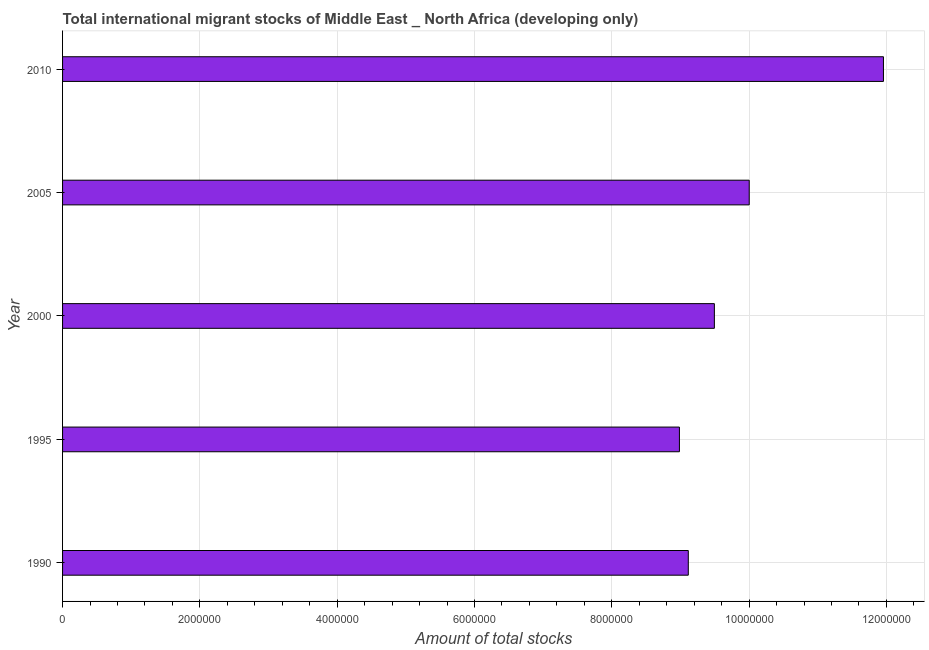What is the title of the graph?
Keep it short and to the point. Total international migrant stocks of Middle East _ North Africa (developing only). What is the label or title of the X-axis?
Offer a terse response. Amount of total stocks. What is the total number of international migrant stock in 1990?
Keep it short and to the point. 9.11e+06. Across all years, what is the maximum total number of international migrant stock?
Make the answer very short. 1.20e+07. Across all years, what is the minimum total number of international migrant stock?
Provide a short and direct response. 8.99e+06. What is the sum of the total number of international migrant stock?
Offer a terse response. 4.96e+07. What is the difference between the total number of international migrant stock in 2005 and 2010?
Provide a succinct answer. -1.96e+06. What is the average total number of international migrant stock per year?
Keep it short and to the point. 9.91e+06. What is the median total number of international migrant stock?
Your response must be concise. 9.49e+06. Do a majority of the years between 1990 and 2005 (inclusive) have total number of international migrant stock greater than 7200000 ?
Keep it short and to the point. Yes. What is the ratio of the total number of international migrant stock in 1995 to that in 2010?
Offer a very short reply. 0.75. Is the total number of international migrant stock in 1995 less than that in 2005?
Offer a very short reply. Yes. Is the difference between the total number of international migrant stock in 2005 and 2010 greater than the difference between any two years?
Give a very brief answer. No. What is the difference between the highest and the second highest total number of international migrant stock?
Offer a terse response. 1.96e+06. What is the difference between the highest and the lowest total number of international migrant stock?
Ensure brevity in your answer.  2.97e+06. In how many years, is the total number of international migrant stock greater than the average total number of international migrant stock taken over all years?
Offer a terse response. 2. Are all the bars in the graph horizontal?
Provide a short and direct response. Yes. How many years are there in the graph?
Make the answer very short. 5. What is the Amount of total stocks of 1990?
Keep it short and to the point. 9.11e+06. What is the Amount of total stocks in 1995?
Your answer should be compact. 8.99e+06. What is the Amount of total stocks in 2000?
Your response must be concise. 9.49e+06. What is the Amount of total stocks in 2005?
Offer a very short reply. 1.00e+07. What is the Amount of total stocks of 2010?
Make the answer very short. 1.20e+07. What is the difference between the Amount of total stocks in 1990 and 1995?
Keep it short and to the point. 1.29e+05. What is the difference between the Amount of total stocks in 1990 and 2000?
Offer a very short reply. -3.80e+05. What is the difference between the Amount of total stocks in 1990 and 2005?
Your answer should be compact. -8.87e+05. What is the difference between the Amount of total stocks in 1990 and 2010?
Your response must be concise. -2.84e+06. What is the difference between the Amount of total stocks in 1995 and 2000?
Make the answer very short. -5.09e+05. What is the difference between the Amount of total stocks in 1995 and 2005?
Provide a short and direct response. -1.02e+06. What is the difference between the Amount of total stocks in 1995 and 2010?
Ensure brevity in your answer.  -2.97e+06. What is the difference between the Amount of total stocks in 2000 and 2005?
Offer a very short reply. -5.08e+05. What is the difference between the Amount of total stocks in 2000 and 2010?
Ensure brevity in your answer.  -2.46e+06. What is the difference between the Amount of total stocks in 2005 and 2010?
Your answer should be very brief. -1.96e+06. What is the ratio of the Amount of total stocks in 1990 to that in 2005?
Your answer should be very brief. 0.91. What is the ratio of the Amount of total stocks in 1990 to that in 2010?
Ensure brevity in your answer.  0.76. What is the ratio of the Amount of total stocks in 1995 to that in 2000?
Make the answer very short. 0.95. What is the ratio of the Amount of total stocks in 1995 to that in 2005?
Your response must be concise. 0.9. What is the ratio of the Amount of total stocks in 1995 to that in 2010?
Offer a very short reply. 0.75. What is the ratio of the Amount of total stocks in 2000 to that in 2005?
Ensure brevity in your answer.  0.95. What is the ratio of the Amount of total stocks in 2000 to that in 2010?
Your answer should be compact. 0.79. What is the ratio of the Amount of total stocks in 2005 to that in 2010?
Provide a short and direct response. 0.84. 